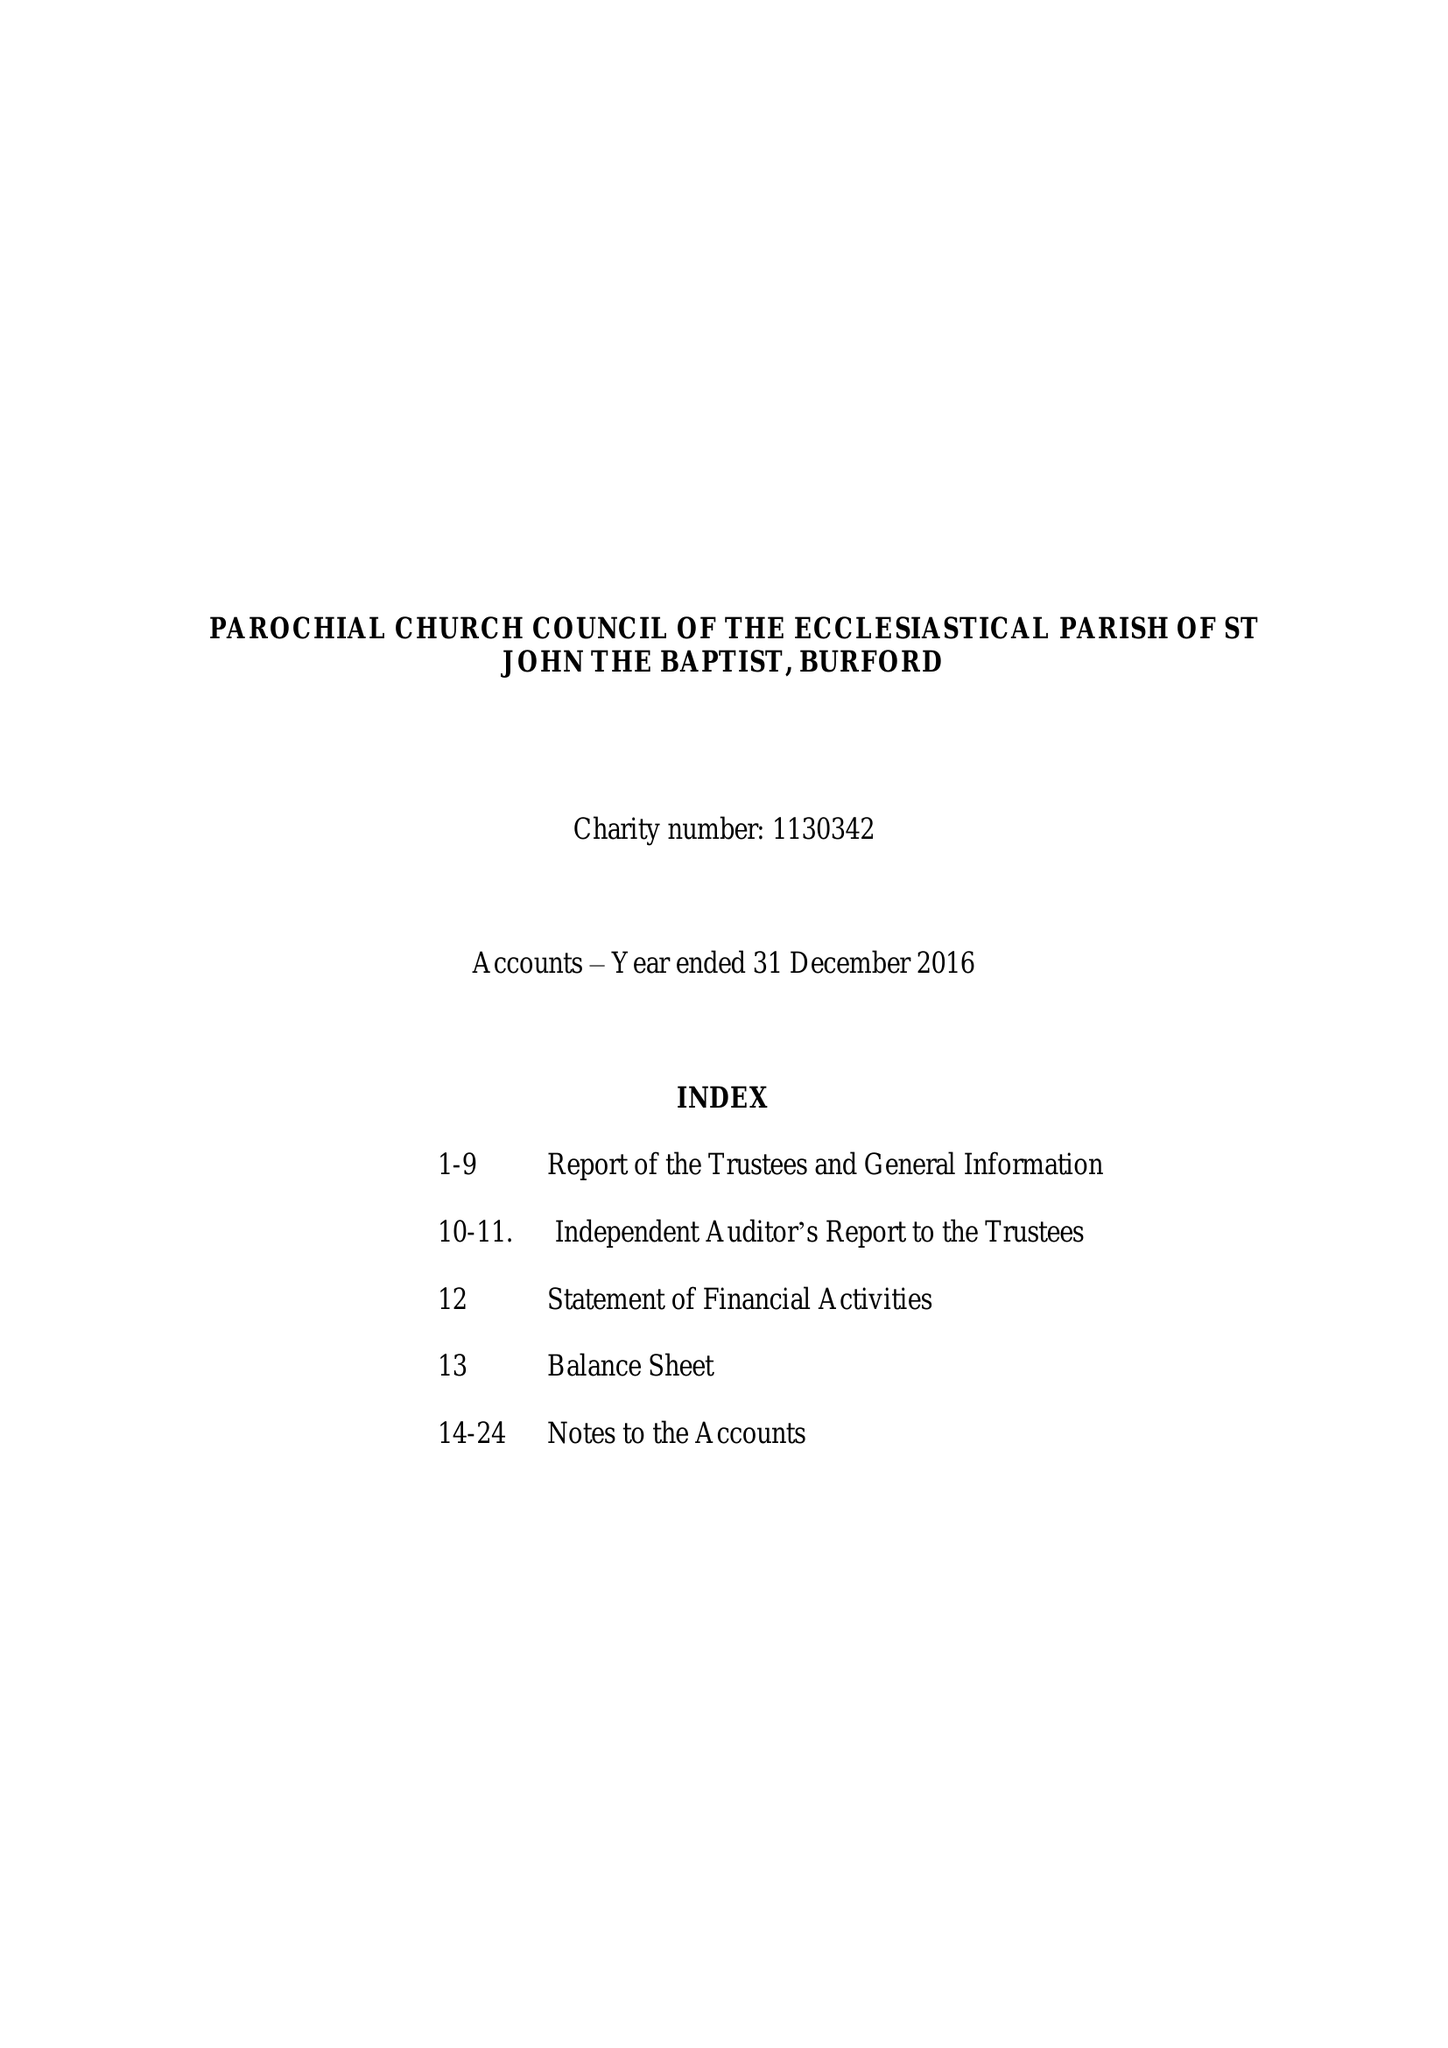What is the value for the spending_annually_in_british_pounds?
Answer the question using a single word or phrase. 351124.00 